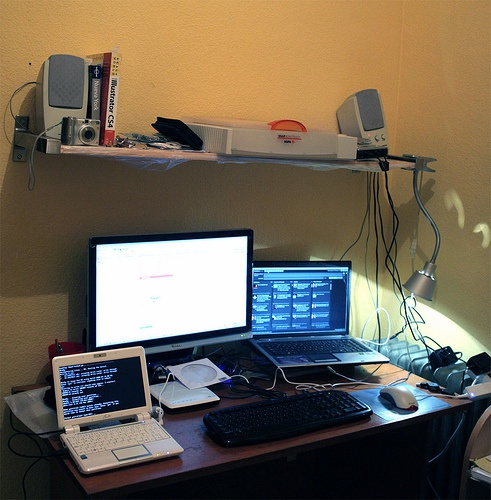Describe the objects in this image and their specific colors. I can see tv in tan, white, black, navy, and gray tones, laptop in tan, darkgray, black, and gray tones, laptop in tan, navy, black, and blue tones, keyboard in tan, black, navy, and blue tones, and keyboard in tan, navy, black, and blue tones in this image. 